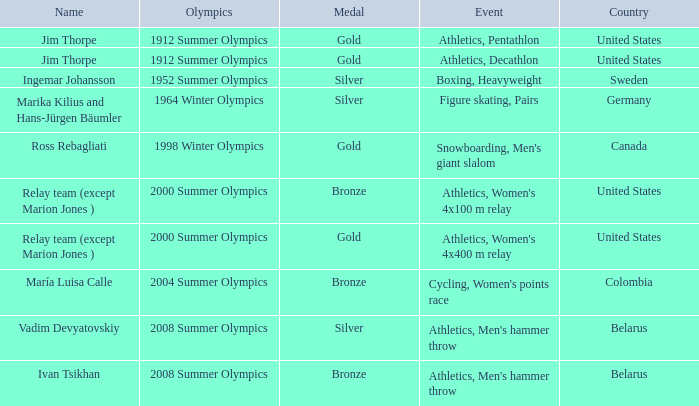What country has a silver medal in the boxing, heavyweight event? Sweden. 